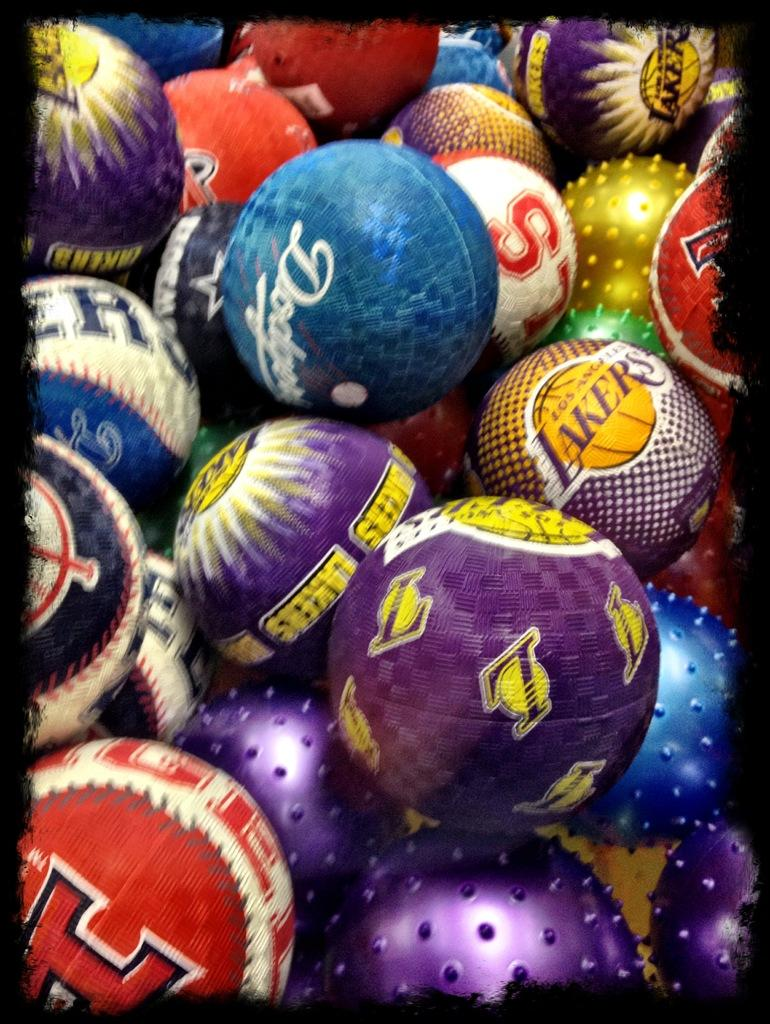What type of objects are present in the image? There are different colored balls in the image. Can you describe the appearance of the balls? The balls have various colors, but no specific details about their size or texture are provided. Are the balls arranged in any particular pattern or order? The facts do not mention any specific arrangement of the balls. What type of book is being read by the apples during breakfast in the image? There is no book, apples, or reference to breakfast in the image; it only features different colored balls. 